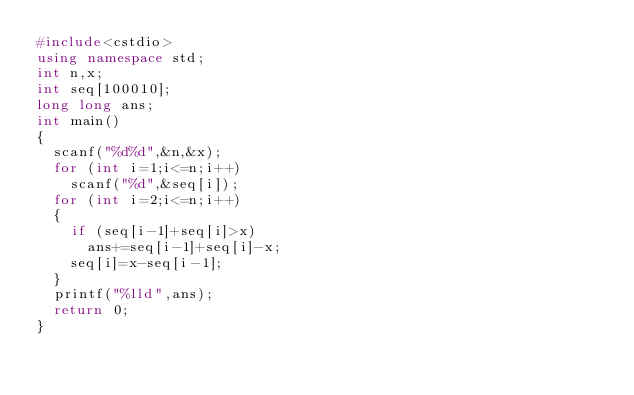Convert code to text. <code><loc_0><loc_0><loc_500><loc_500><_C++_>#include<cstdio>
using namespace std;
int n,x;
int seq[100010];
long long ans;
int main()
{
	scanf("%d%d",&n,&x);
	for (int i=1;i<=n;i++)
		scanf("%d",&seq[i]);
	for (int i=2;i<=n;i++)
	{
		if (seq[i-1]+seq[i]>x)
			ans+=seq[i-1]+seq[i]-x;
		seq[i]=x-seq[i-1];
	}
	printf("%lld",ans);
	return 0;
}</code> 